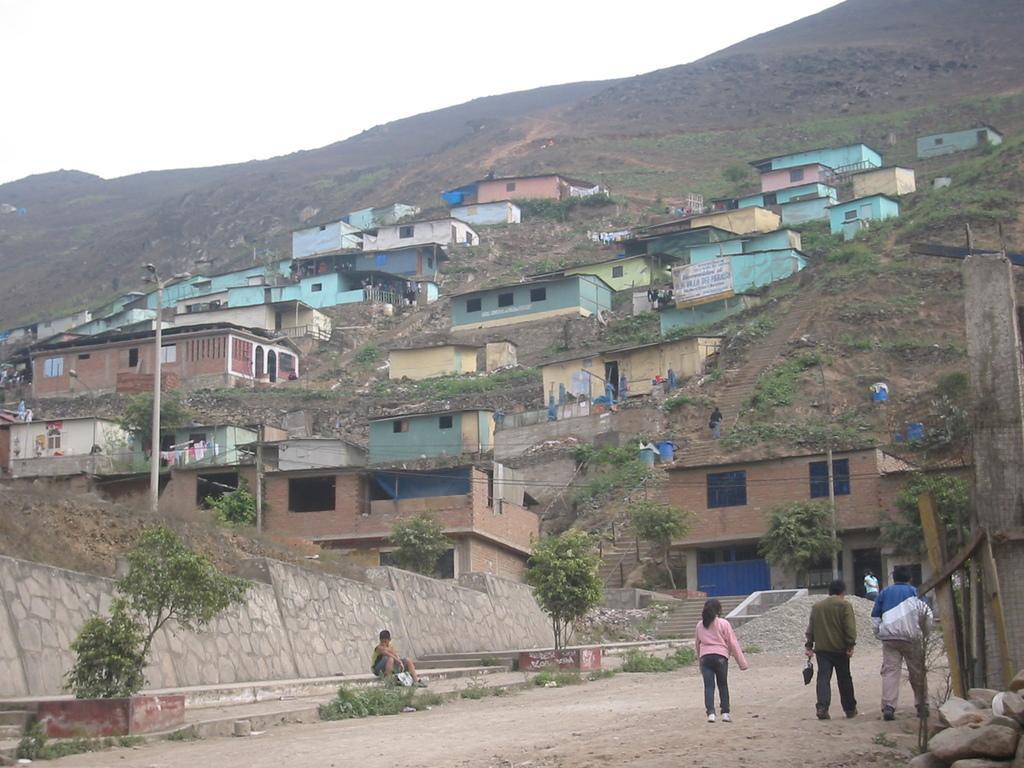Please provide a concise description of this image. In this picture we can see people on the ground, here we can see houses, trees, poles and some objects and we can see sky in the background. 